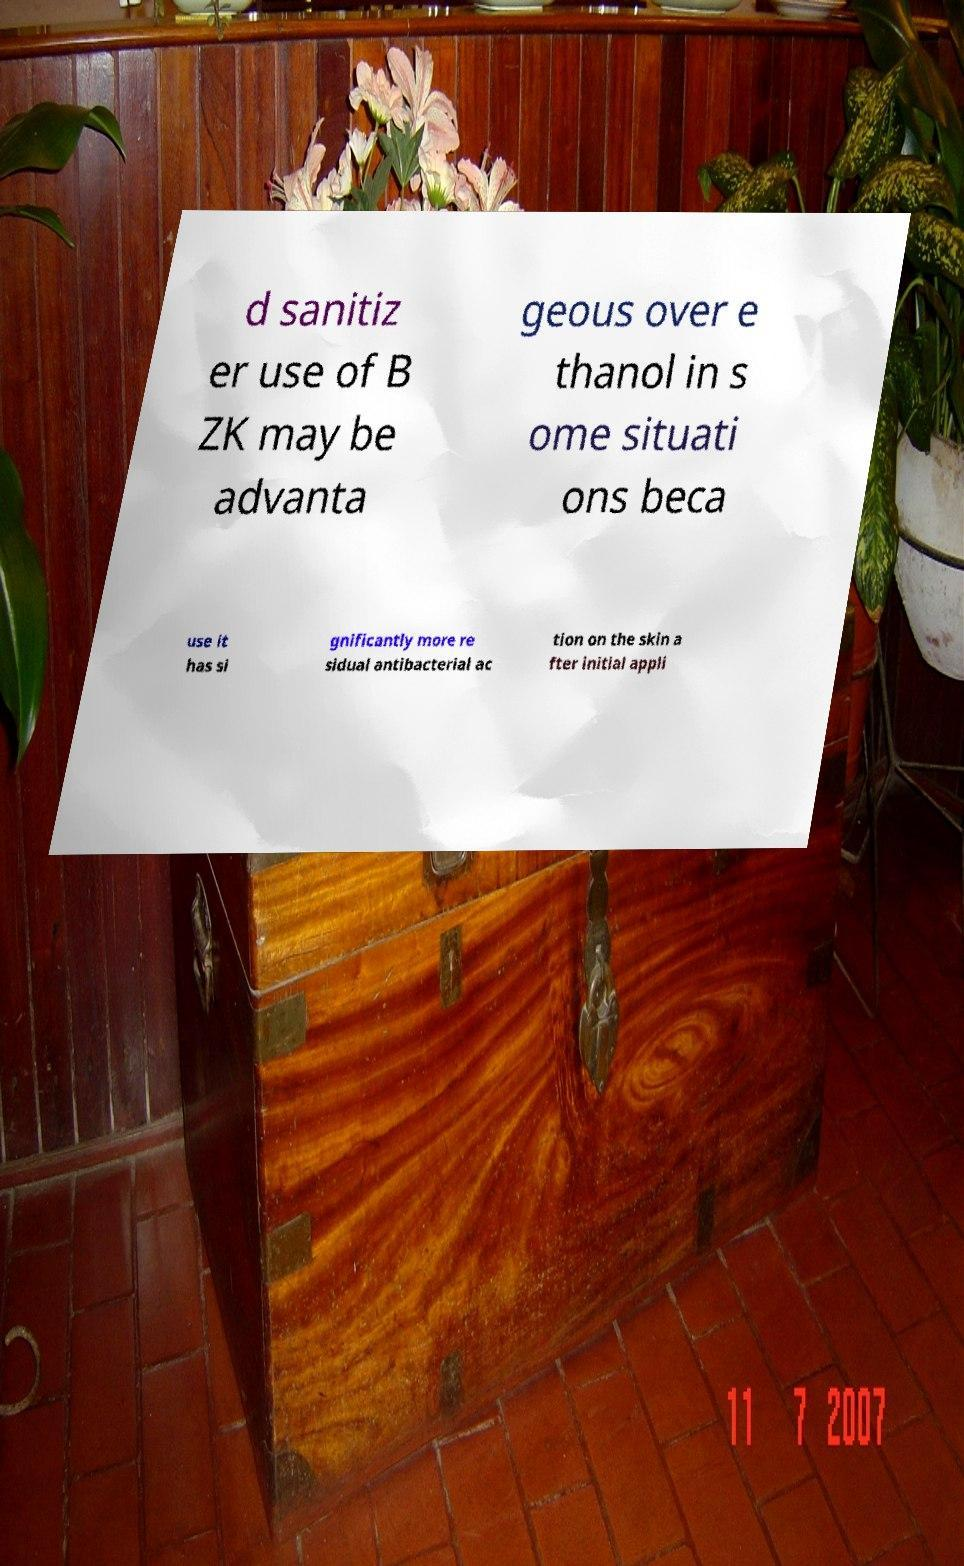Can you read and provide the text displayed in the image?This photo seems to have some interesting text. Can you extract and type it out for me? d sanitiz er use of B ZK may be advanta geous over e thanol in s ome situati ons beca use it has si gnificantly more re sidual antibacterial ac tion on the skin a fter initial appli 